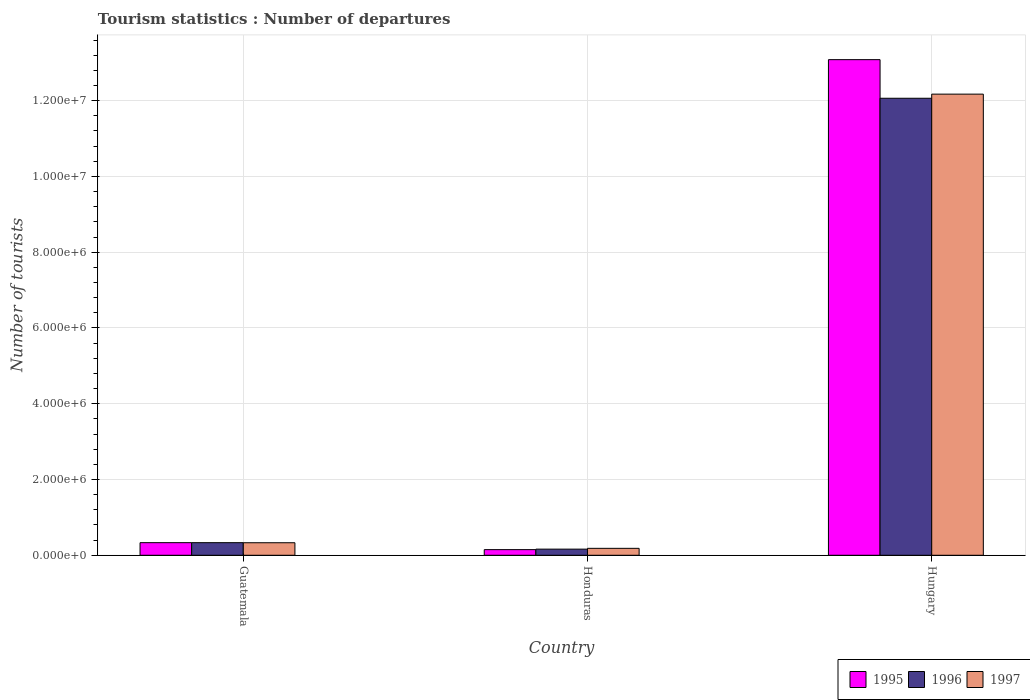How many different coloured bars are there?
Offer a terse response. 3. How many groups of bars are there?
Your answer should be compact. 3. What is the label of the 2nd group of bars from the left?
Your response must be concise. Honduras. What is the number of tourist departures in 1996 in Guatemala?
Ensure brevity in your answer.  3.33e+05. Across all countries, what is the maximum number of tourist departures in 1996?
Your answer should be compact. 1.21e+07. Across all countries, what is the minimum number of tourist departures in 1997?
Ensure brevity in your answer.  1.83e+05. In which country was the number of tourist departures in 1996 maximum?
Provide a short and direct response. Hungary. In which country was the number of tourist departures in 1997 minimum?
Your response must be concise. Honduras. What is the total number of tourist departures in 1995 in the graph?
Your answer should be compact. 1.36e+07. What is the difference between the number of tourist departures in 1996 in Guatemala and that in Honduras?
Your response must be concise. 1.71e+05. What is the average number of tourist departures in 1997 per country?
Offer a terse response. 4.23e+06. What is the difference between the number of tourist departures of/in 1997 and number of tourist departures of/in 1996 in Hungary?
Keep it short and to the point. 1.09e+05. What is the ratio of the number of tourist departures in 1997 in Honduras to that in Hungary?
Provide a succinct answer. 0.02. Is the number of tourist departures in 1997 in Guatemala less than that in Hungary?
Provide a short and direct response. Yes. Is the difference between the number of tourist departures in 1997 in Guatemala and Honduras greater than the difference between the number of tourist departures in 1996 in Guatemala and Honduras?
Provide a succinct answer. No. What is the difference between the highest and the second highest number of tourist departures in 1996?
Provide a short and direct response. 1.19e+07. What is the difference between the highest and the lowest number of tourist departures in 1996?
Give a very brief answer. 1.19e+07. What does the 1st bar from the left in Hungary represents?
Ensure brevity in your answer.  1995. How many bars are there?
Make the answer very short. 9. Are the values on the major ticks of Y-axis written in scientific E-notation?
Provide a short and direct response. Yes. How are the legend labels stacked?
Your response must be concise. Horizontal. What is the title of the graph?
Your answer should be very brief. Tourism statistics : Number of departures. Does "2003" appear as one of the legend labels in the graph?
Make the answer very short. No. What is the label or title of the X-axis?
Make the answer very short. Country. What is the label or title of the Y-axis?
Your response must be concise. Number of tourists. What is the Number of tourists of 1995 in Guatemala?
Provide a succinct answer. 3.33e+05. What is the Number of tourists in 1996 in Guatemala?
Make the answer very short. 3.33e+05. What is the Number of tourists in 1997 in Guatemala?
Offer a terse response. 3.31e+05. What is the Number of tourists of 1995 in Honduras?
Ensure brevity in your answer.  1.49e+05. What is the Number of tourists in 1996 in Honduras?
Offer a terse response. 1.62e+05. What is the Number of tourists in 1997 in Honduras?
Give a very brief answer. 1.83e+05. What is the Number of tourists of 1995 in Hungary?
Your response must be concise. 1.31e+07. What is the Number of tourists in 1996 in Hungary?
Provide a succinct answer. 1.21e+07. What is the Number of tourists of 1997 in Hungary?
Your answer should be compact. 1.22e+07. Across all countries, what is the maximum Number of tourists of 1995?
Your response must be concise. 1.31e+07. Across all countries, what is the maximum Number of tourists of 1996?
Offer a terse response. 1.21e+07. Across all countries, what is the maximum Number of tourists of 1997?
Keep it short and to the point. 1.22e+07. Across all countries, what is the minimum Number of tourists of 1995?
Your response must be concise. 1.49e+05. Across all countries, what is the minimum Number of tourists of 1996?
Ensure brevity in your answer.  1.62e+05. Across all countries, what is the minimum Number of tourists of 1997?
Make the answer very short. 1.83e+05. What is the total Number of tourists in 1995 in the graph?
Ensure brevity in your answer.  1.36e+07. What is the total Number of tourists in 1996 in the graph?
Ensure brevity in your answer.  1.26e+07. What is the total Number of tourists in 1997 in the graph?
Your answer should be very brief. 1.27e+07. What is the difference between the Number of tourists in 1995 in Guatemala and that in Honduras?
Your response must be concise. 1.84e+05. What is the difference between the Number of tourists of 1996 in Guatemala and that in Honduras?
Your response must be concise. 1.71e+05. What is the difference between the Number of tourists in 1997 in Guatemala and that in Honduras?
Your answer should be very brief. 1.48e+05. What is the difference between the Number of tourists of 1995 in Guatemala and that in Hungary?
Ensure brevity in your answer.  -1.28e+07. What is the difference between the Number of tourists of 1996 in Guatemala and that in Hungary?
Your answer should be compact. -1.17e+07. What is the difference between the Number of tourists of 1997 in Guatemala and that in Hungary?
Your answer should be compact. -1.18e+07. What is the difference between the Number of tourists in 1995 in Honduras and that in Hungary?
Your answer should be very brief. -1.29e+07. What is the difference between the Number of tourists of 1996 in Honduras and that in Hungary?
Offer a terse response. -1.19e+07. What is the difference between the Number of tourists of 1997 in Honduras and that in Hungary?
Your response must be concise. -1.20e+07. What is the difference between the Number of tourists of 1995 in Guatemala and the Number of tourists of 1996 in Honduras?
Your answer should be very brief. 1.71e+05. What is the difference between the Number of tourists in 1995 in Guatemala and the Number of tourists in 1996 in Hungary?
Provide a succinct answer. -1.17e+07. What is the difference between the Number of tourists of 1995 in Guatemala and the Number of tourists of 1997 in Hungary?
Your response must be concise. -1.18e+07. What is the difference between the Number of tourists in 1996 in Guatemala and the Number of tourists in 1997 in Hungary?
Offer a terse response. -1.18e+07. What is the difference between the Number of tourists in 1995 in Honduras and the Number of tourists in 1996 in Hungary?
Your answer should be compact. -1.19e+07. What is the difference between the Number of tourists of 1995 in Honduras and the Number of tourists of 1997 in Hungary?
Your response must be concise. -1.20e+07. What is the difference between the Number of tourists of 1996 in Honduras and the Number of tourists of 1997 in Hungary?
Offer a terse response. -1.20e+07. What is the average Number of tourists of 1995 per country?
Offer a terse response. 4.52e+06. What is the average Number of tourists of 1996 per country?
Offer a very short reply. 4.19e+06. What is the average Number of tourists in 1997 per country?
Give a very brief answer. 4.23e+06. What is the difference between the Number of tourists in 1996 and Number of tourists in 1997 in Guatemala?
Offer a terse response. 2000. What is the difference between the Number of tourists in 1995 and Number of tourists in 1996 in Honduras?
Give a very brief answer. -1.30e+04. What is the difference between the Number of tourists of 1995 and Number of tourists of 1997 in Honduras?
Provide a succinct answer. -3.40e+04. What is the difference between the Number of tourists of 1996 and Number of tourists of 1997 in Honduras?
Keep it short and to the point. -2.10e+04. What is the difference between the Number of tourists of 1995 and Number of tourists of 1996 in Hungary?
Offer a terse response. 1.02e+06. What is the difference between the Number of tourists in 1995 and Number of tourists in 1997 in Hungary?
Keep it short and to the point. 9.10e+05. What is the difference between the Number of tourists in 1996 and Number of tourists in 1997 in Hungary?
Provide a short and direct response. -1.09e+05. What is the ratio of the Number of tourists of 1995 in Guatemala to that in Honduras?
Provide a succinct answer. 2.23. What is the ratio of the Number of tourists of 1996 in Guatemala to that in Honduras?
Offer a terse response. 2.06. What is the ratio of the Number of tourists of 1997 in Guatemala to that in Honduras?
Ensure brevity in your answer.  1.81. What is the ratio of the Number of tourists in 1995 in Guatemala to that in Hungary?
Keep it short and to the point. 0.03. What is the ratio of the Number of tourists in 1996 in Guatemala to that in Hungary?
Provide a succinct answer. 0.03. What is the ratio of the Number of tourists in 1997 in Guatemala to that in Hungary?
Offer a terse response. 0.03. What is the ratio of the Number of tourists in 1995 in Honduras to that in Hungary?
Your answer should be compact. 0.01. What is the ratio of the Number of tourists in 1996 in Honduras to that in Hungary?
Give a very brief answer. 0.01. What is the ratio of the Number of tourists of 1997 in Honduras to that in Hungary?
Your response must be concise. 0.01. What is the difference between the highest and the second highest Number of tourists in 1995?
Your response must be concise. 1.28e+07. What is the difference between the highest and the second highest Number of tourists of 1996?
Your response must be concise. 1.17e+07. What is the difference between the highest and the second highest Number of tourists of 1997?
Provide a succinct answer. 1.18e+07. What is the difference between the highest and the lowest Number of tourists of 1995?
Offer a terse response. 1.29e+07. What is the difference between the highest and the lowest Number of tourists in 1996?
Offer a terse response. 1.19e+07. What is the difference between the highest and the lowest Number of tourists in 1997?
Keep it short and to the point. 1.20e+07. 